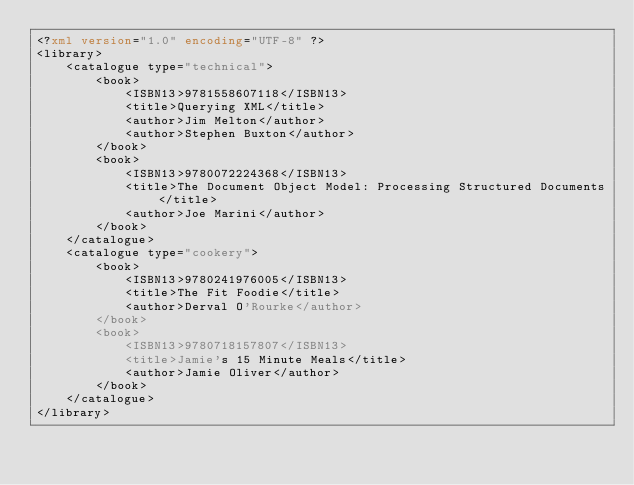<code> <loc_0><loc_0><loc_500><loc_500><_XML_><?xml version="1.0" encoding="UTF-8" ?>
<library>
    <catalogue type="technical">
        <book>
            <ISBN13>9781558607118</ISBN13>
            <title>Querying XML</title>
            <author>Jim Melton</author>
            <author>Stephen Buxton</author>
        </book>
        <book>
            <ISBN13>9780072224368</ISBN13>
            <title>The Document Object Model: Processing Structured Documents</title>
            <author>Joe Marini</author> 
        </book>
    </catalogue>
    <catalogue type="cookery">
        <book>
            <ISBN13>9780241976005</ISBN13>
            <title>The Fit Foodie</title>
            <author>Derval O'Rourke</author> 
        </book>
        <book>
            <ISBN13>9780718157807</ISBN13>
            <title>Jamie's 15 Minute Meals</title>
            <author>Jamie Oliver</author> 
        </book>
    </catalogue>
</library></code> 